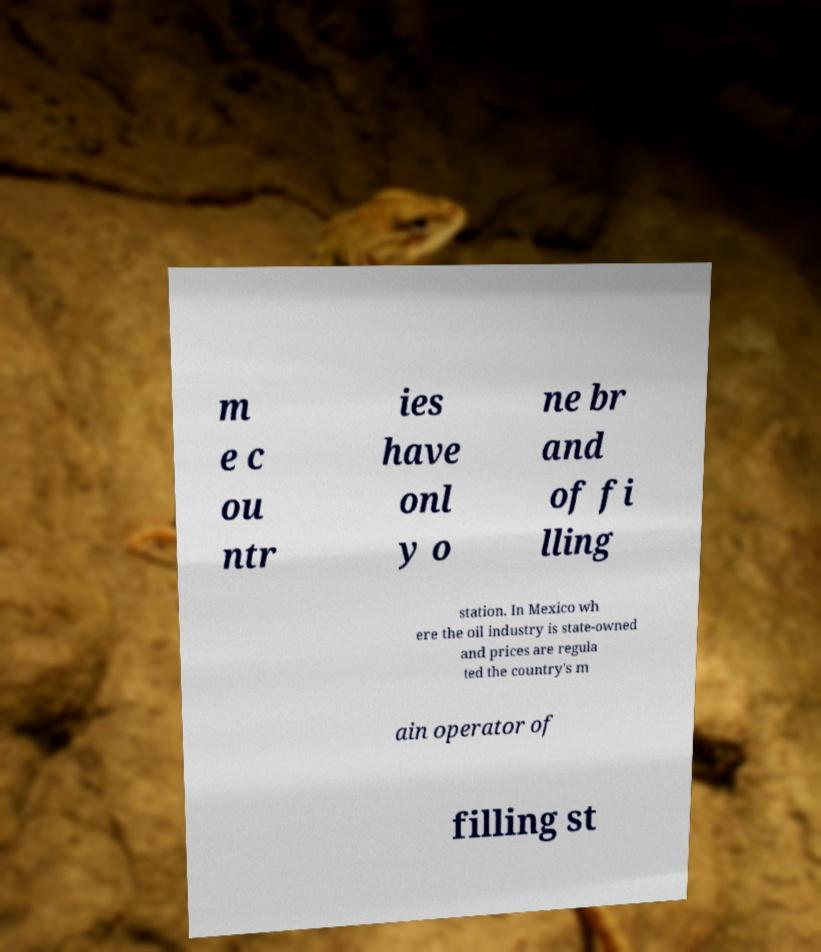I need the written content from this picture converted into text. Can you do that? m e c ou ntr ies have onl y o ne br and of fi lling station. In Mexico wh ere the oil industry is state-owned and prices are regula ted the country's m ain operator of filling st 